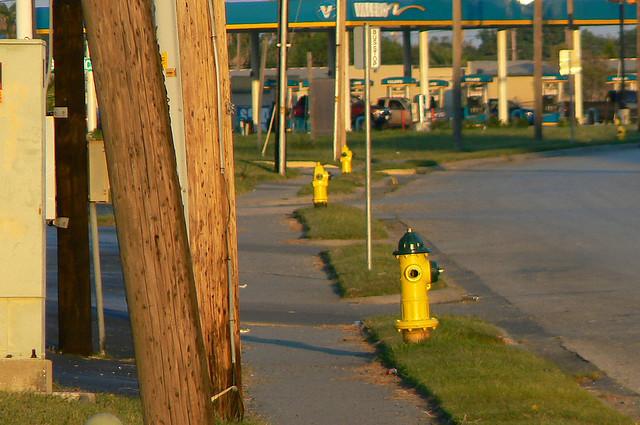What color are the hydrants?
Be succinct. Yellow. What is the fence made out of?
Answer briefly. Wood. Is this a busy street?
Short answer required. No. Is there a gas station nearby?
Quick response, please. Yes. 